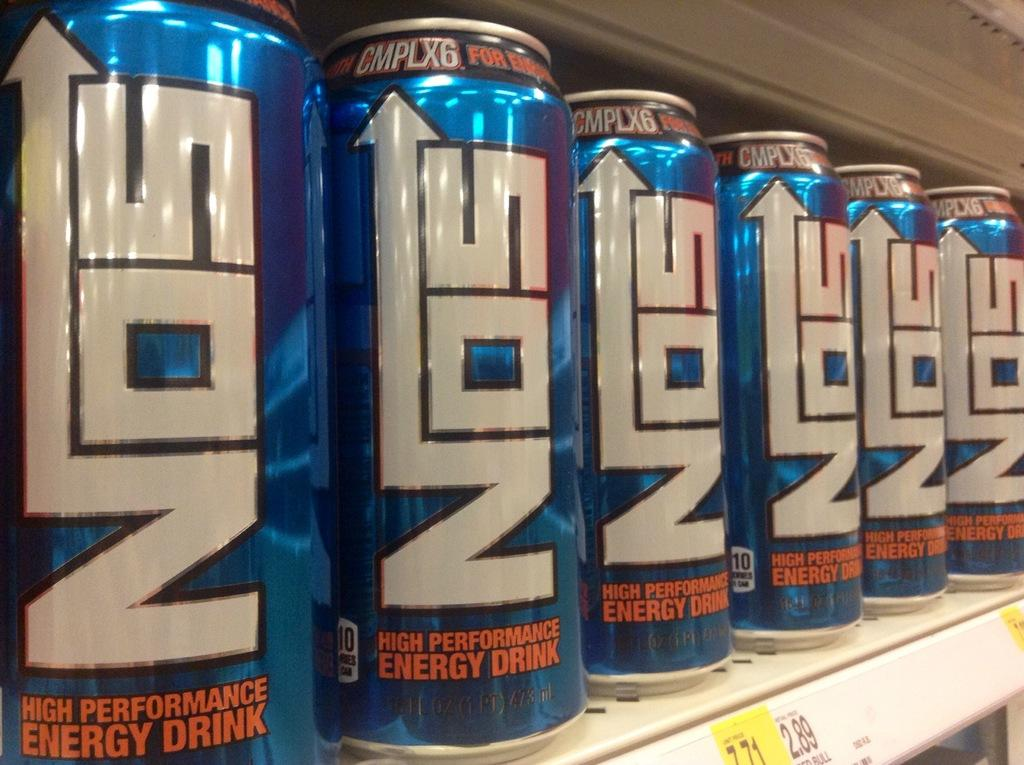<image>
Render a clear and concise summary of the photo. some nos that are all lined up with each other 